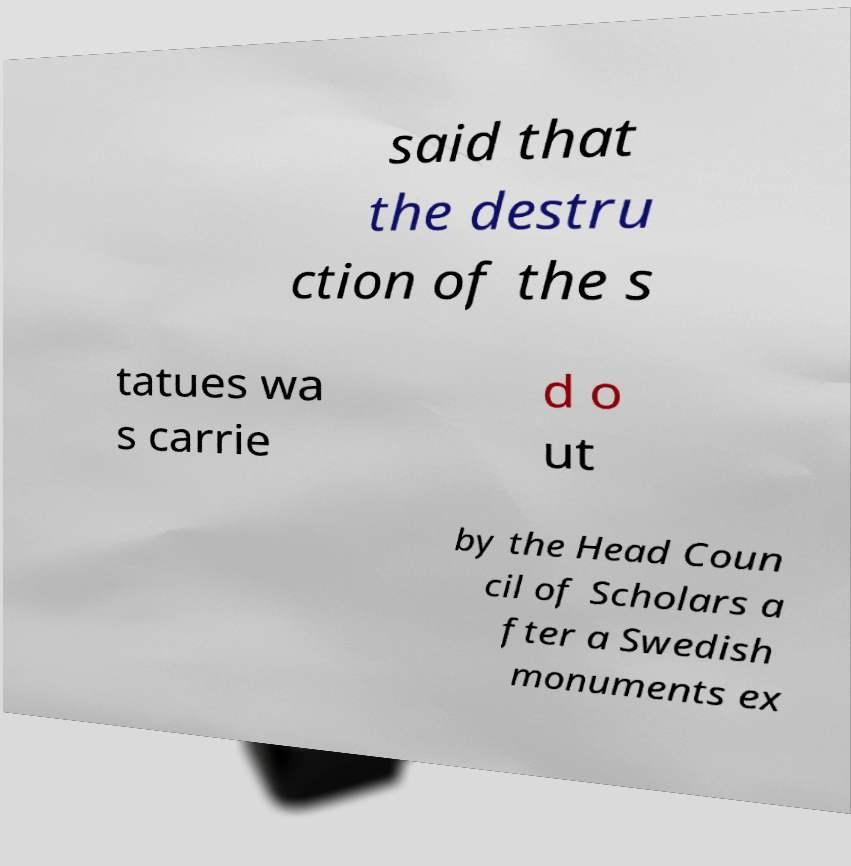For documentation purposes, I need the text within this image transcribed. Could you provide that? said that the destru ction of the s tatues wa s carrie d o ut by the Head Coun cil of Scholars a fter a Swedish monuments ex 